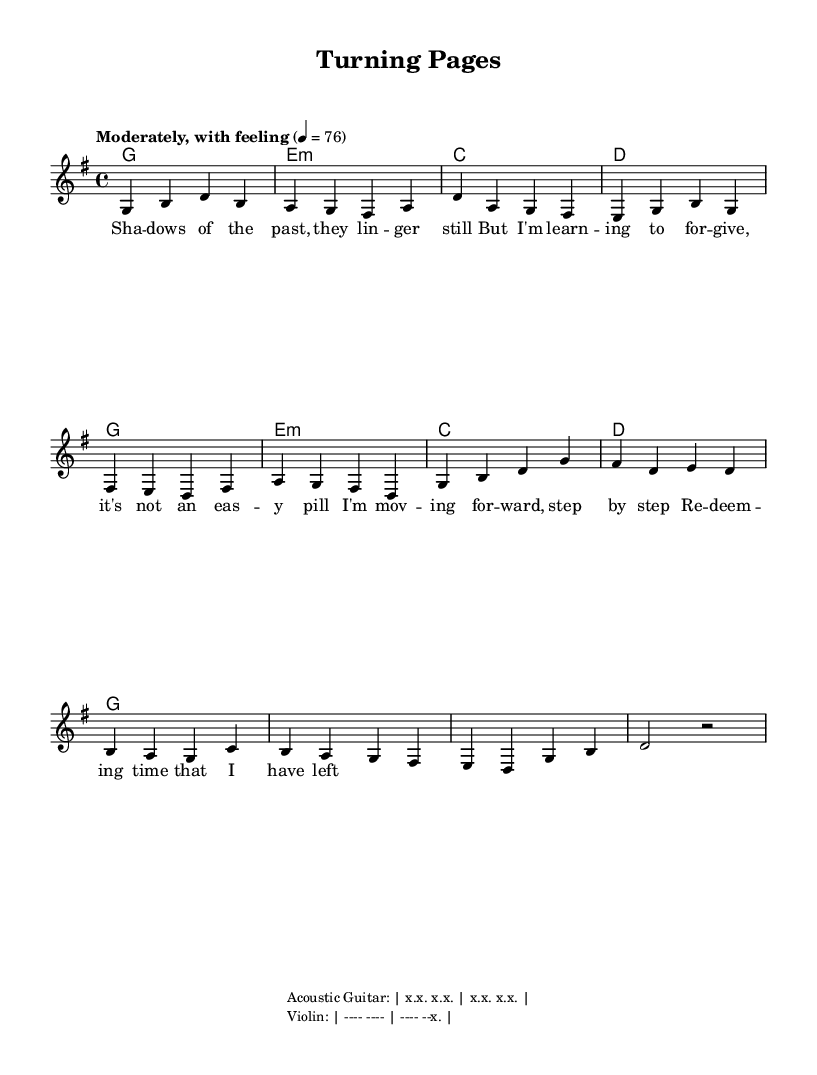What is the key signature of this music? The key signature is G major, which has one sharp (F#). You can identify the key signature in the global settings at the top of the code where it states "\key g \major".
Answer: G major What is the time signature of this music? The time signature is 4/4, which is indicated in the global settings as "\time 4/4". This means there are four beats in each measure.
Answer: 4/4 What is the tempo marking for this piece? The tempo marking is "Moderately, with feeling", which is indicated in the global settings. Additionally, it states "4 = 76", indicating the beats per minute.
Answer: Moderately, with feeling How many measures are there in the verse? The verse section consists of 6 measures as indicated by the number of groups of notes written in the melody section. Counting each bar, we see there are 6 distinct measures.
Answer: 6 What instrument primarily carries the melody? The melody is primarily carried by the lead voice, which is indicated in the score as being a new voice called "lead". The melody starts immediately after the chord names and contains the main musical line.
Answer: Voice What theme is explored in this contemporary folk music? The theme of this contemporary folk music is redemption and moving forward, as evidenced by the lyrics discussing forgiveness and learning from the past. This theme is significant in folk music, often providing personal narratives.
Answer: Redemption and moving forward What type of musical accompaniment is indicated for this piece? The accompaniment includes acoustic guitar and violin. This is seen in the markup section where instrument specifications are provided below the music staff.
Answer: Acoustic Guitar and Violin 